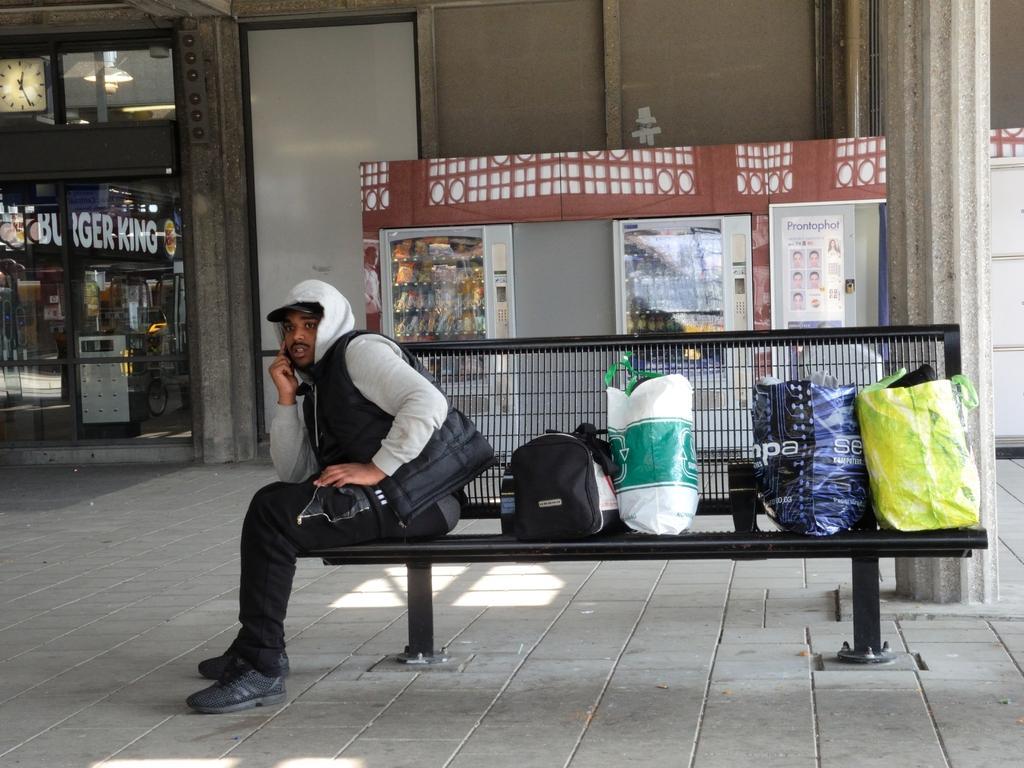Describe this image in one or two sentences. This picture shows a man seated on a metal bench and we see few bags and we see a building and couple of vending machines 